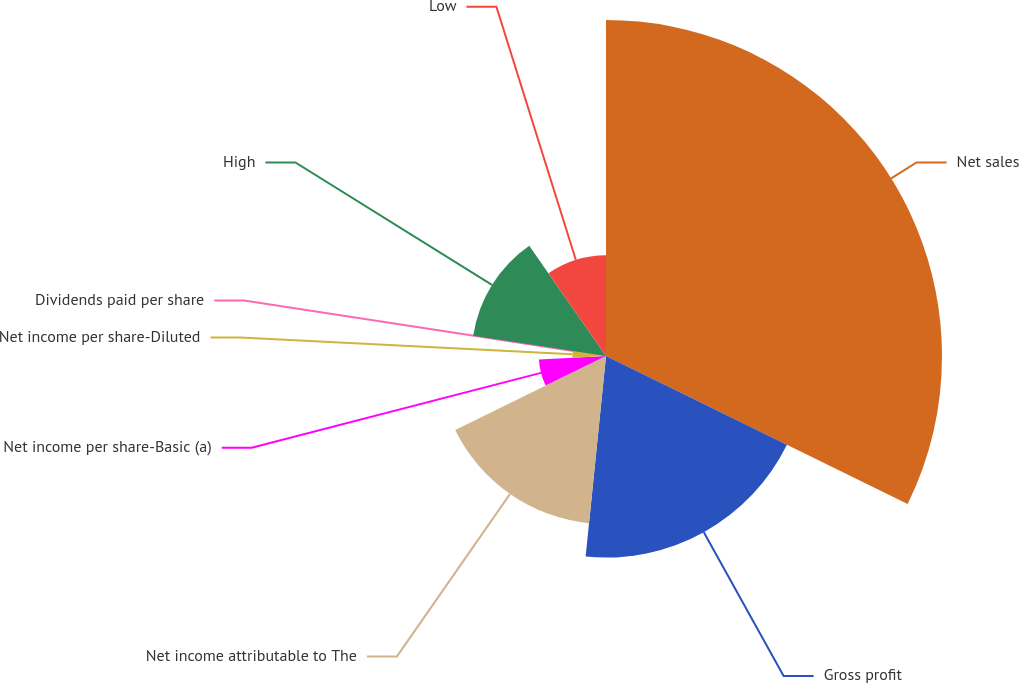Convert chart. <chart><loc_0><loc_0><loc_500><loc_500><pie_chart><fcel>Net sales<fcel>Gross profit<fcel>Net income attributable to The<fcel>Net income per share-Basic (a)<fcel>Net income per share-Diluted<fcel>Dividends paid per share<fcel>High<fcel>Low<nl><fcel>32.26%<fcel>19.35%<fcel>16.13%<fcel>6.45%<fcel>3.23%<fcel>0.0%<fcel>12.9%<fcel>9.68%<nl></chart> 